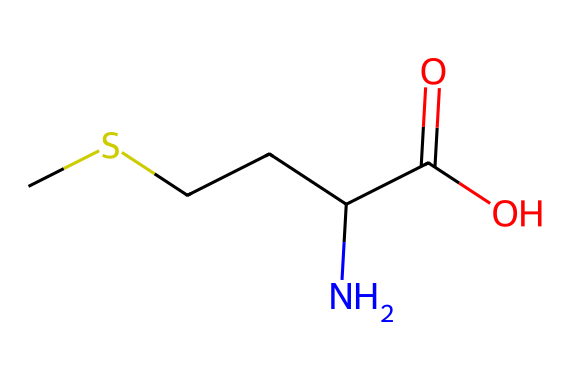What is the molecular formula of methionine? The SMILES representation indicates the number of each type of atom present. Counting the atoms from the structure reveals there are 5 carbon atoms, 11 hydrogen atoms, 1 nitrogen atom, 1 oxygen atom, and 1 sulfur atom. Thus, the molecular formula is C5H11NOS.
Answer: C5H11NOS How many carbon atoms are present in methionine? By examining the SMILES string, there are five distinct carbon atoms represented. Counting them yields a total of five.
Answer: 5 What functional group is present in methionine? The structure contains a carboxylic acid group (–COOH), indicated by the carbon atom double-bonded to an oxygen atom and single-bonded to a hydroxyl group. This characteristic defines a carboxylic acid functional group.
Answer: carboxylic acid What type of amino acid is methionine? Methionine is classified as an essential amino acid due to the presence of a sulfur atom in its side chain (the thioether group). Essential amino acids are those that must be obtained through diet since the body cannot synthesize them.
Answer: essential What role does the sulfur atom play in the structure of methionine? The sulfur atom in methionine contributes to its unique properties and functions, including its role in protein synthesis and as a methyl donor in various biochemical processes. Additionally, the presence of sulfur affects the properties of the amino acid, distinguishing it from others.
Answer: methyl donor Did methionine have any specific dietary functions? Methionine plays a key role in metabolism, serving as a precursor for other important compounds (such as S-adenosylmethionine) and is essential in the growth and repair of tissues. Its dietary functions are crucial for numerous cellular processes.
Answer: metabolism 